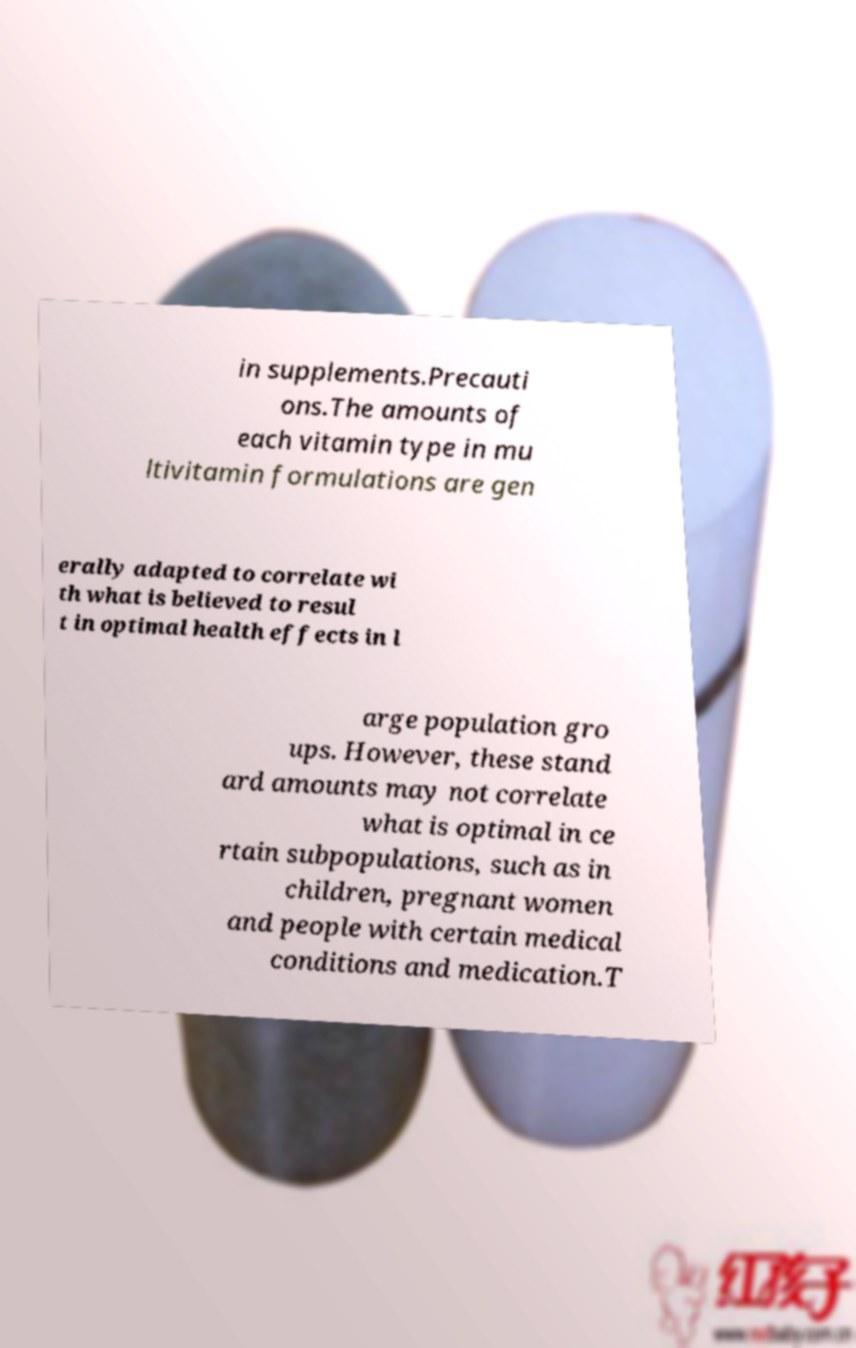Could you extract and type out the text from this image? in supplements.Precauti ons.The amounts of each vitamin type in mu ltivitamin formulations are gen erally adapted to correlate wi th what is believed to resul t in optimal health effects in l arge population gro ups. However, these stand ard amounts may not correlate what is optimal in ce rtain subpopulations, such as in children, pregnant women and people with certain medical conditions and medication.T 